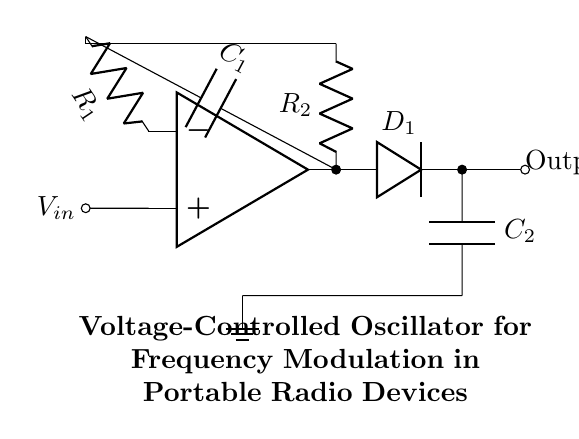What type of oscillator is illustrated in the circuit? The circuit represents a voltage-controlled oscillator (VCO), indicated by the presence of a variable capacitance component (the varactor diode) that is controlled by an input voltage.
Answer: Voltage-controlled oscillator What are the two capacitance components in the circuit? The circuit includes two capacitors: C1, connected to the op-amp, and C2, connected to the varactor. Both are critical for the oscillator's function.
Answer: C1 and C2 What is the role of the op-amp in this circuit? The op-amp amplifies the input voltage signal and provides the essential feedback loop, which is vital for generating oscillations.
Answer: Amplification How many resistors are present in the circuit and what are their labels? There are two resistors labeled as R1 and R2, which are part of the feedback network, influencing the oscillation frequency and stability.
Answer: Two, R1 and R2 Why does this circuit utilize a varactor diode? The varactor diode is used to create a voltage-dependent capacitance that allows the circuit to change its frequency based on the control voltage input, crucial for frequency modulation.
Answer: Frequency modulation What is the purpose of the feedback loop in the oscillator circuit? The feedback loop connects the output back to the input, crucial for sustaining oscillation and determining the frequency of the oscillator.
Answer: Sustain oscillation 